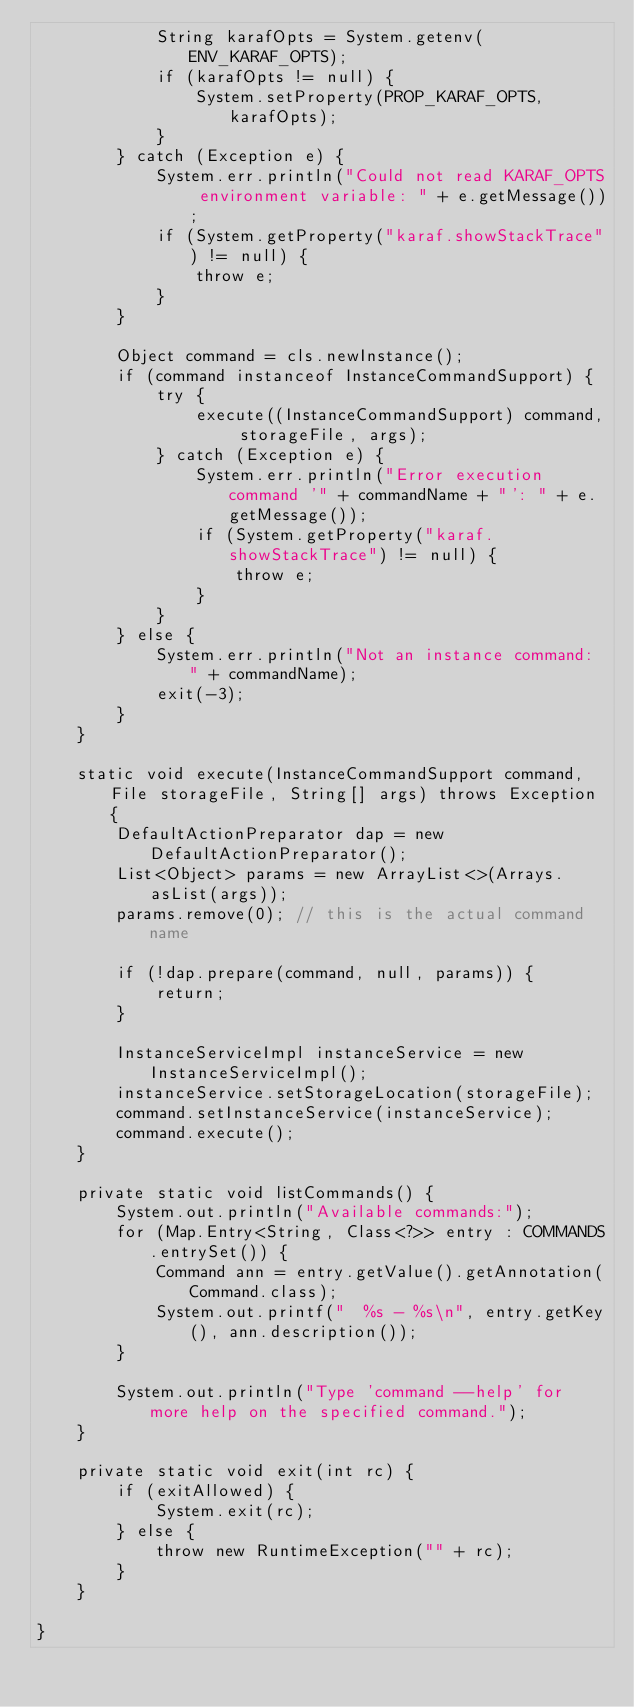<code> <loc_0><loc_0><loc_500><loc_500><_Java_>            String karafOpts = System.getenv(ENV_KARAF_OPTS);
            if (karafOpts != null) {
                System.setProperty(PROP_KARAF_OPTS, karafOpts);
            }
        } catch (Exception e) {
            System.err.println("Could not read KARAF_OPTS environment variable: " + e.getMessage());
            if (System.getProperty("karaf.showStackTrace") != null) {
                throw e;
            }
        }

        Object command = cls.newInstance();
        if (command instanceof InstanceCommandSupport) {
            try {
                execute((InstanceCommandSupport) command, storageFile, args);
            } catch (Exception e) {
                System.err.println("Error execution command '" + commandName + "': " + e.getMessage());
                if (System.getProperty("karaf.showStackTrace") != null) {
                    throw e;
                }
            }
        } else {
            System.err.println("Not an instance command: " + commandName);
            exit(-3);
        }
    }

    static void execute(InstanceCommandSupport command, File storageFile, String[] args) throws Exception {
        DefaultActionPreparator dap = new DefaultActionPreparator();
        List<Object> params = new ArrayList<>(Arrays.asList(args));
        params.remove(0); // this is the actual command name

        if (!dap.prepare(command, null, params)) {
            return;
        }

        InstanceServiceImpl instanceService = new InstanceServiceImpl();
        instanceService.setStorageLocation(storageFile);
        command.setInstanceService(instanceService);
        command.execute();
    }

    private static void listCommands() {
        System.out.println("Available commands:");
        for (Map.Entry<String, Class<?>> entry : COMMANDS.entrySet()) {
            Command ann = entry.getValue().getAnnotation(Command.class);
            System.out.printf("  %s - %s\n", entry.getKey(), ann.description());
        }

        System.out.println("Type 'command --help' for more help on the specified command.");
    }

    private static void exit(int rc) {
        if (exitAllowed) {
            System.exit(rc);
        } else {
            throw new RuntimeException("" + rc);
        }
    }

}
</code> 